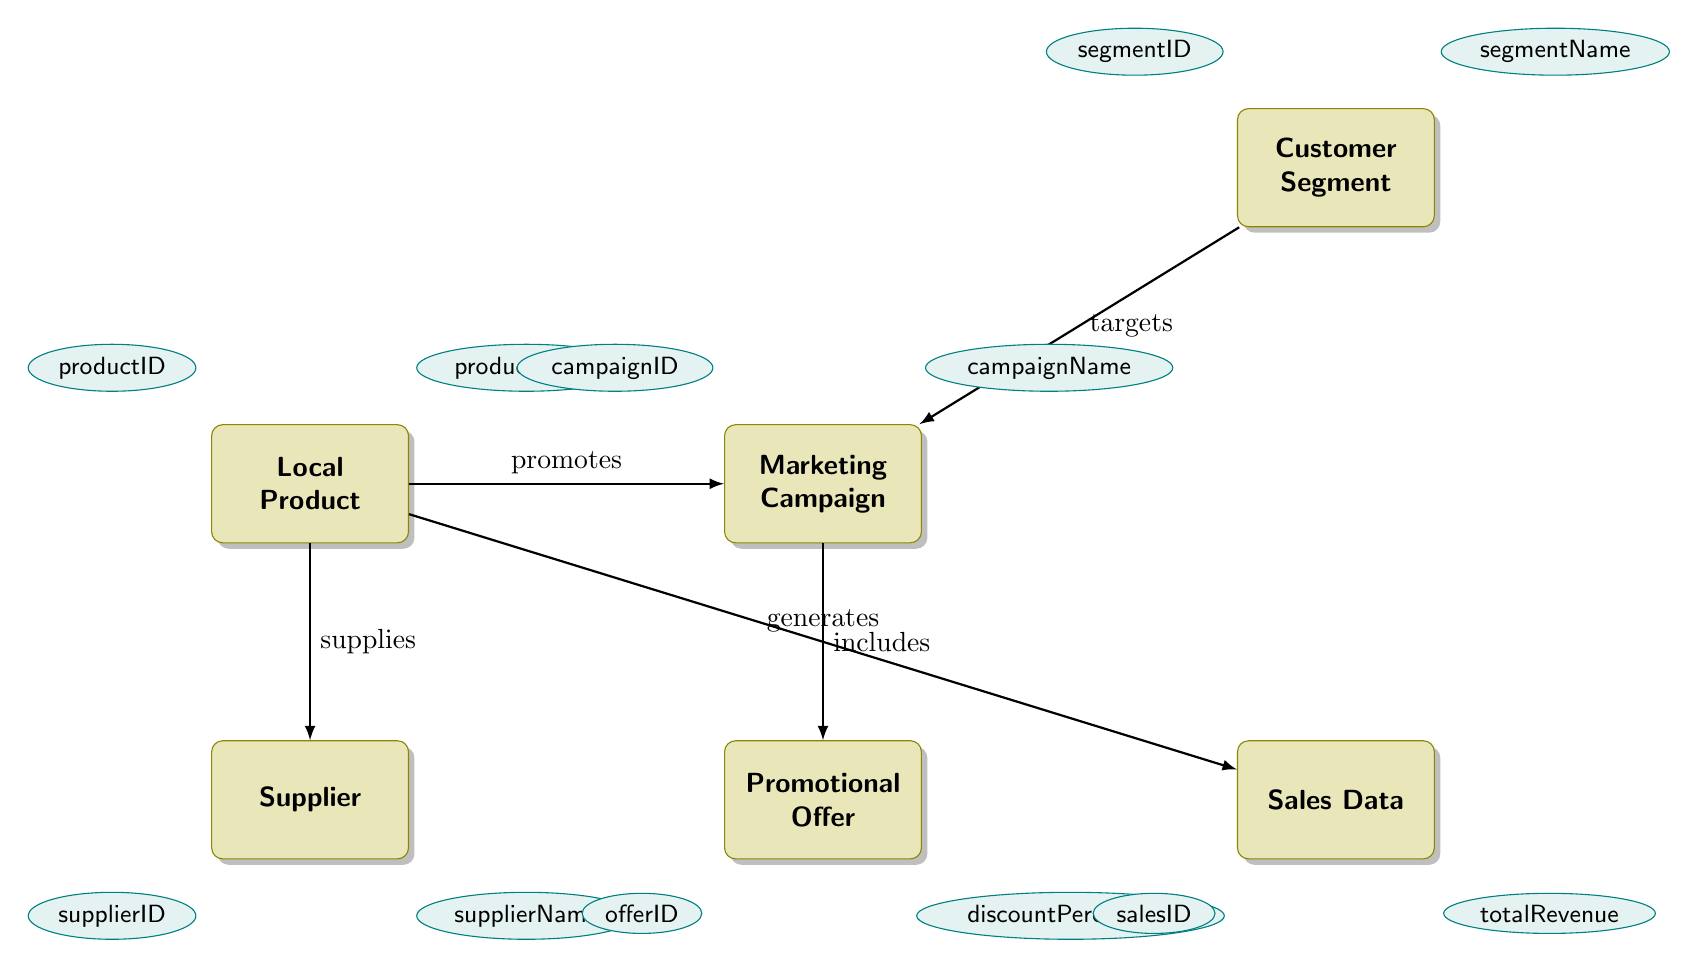What is the primary relationship between Local Product and Supplier? The diagram shows that Local Product has a "ManyToOne" relationship with Supplier, indicating that multiple local products can be supplied by a single supplier.
Answer: ManyToOne How many attributes does the Marketing Campaign entity have? By examining the Marketing Campaign entity in the diagram, we see that it has five attributes: campaignID, campaignName, startDate, endDate, and budget.
Answer: Five Which entity targets Customer Segments in the marketing structure? The diagram indicates that Marketing Campaign has a "ManyToMany" relationship with Customer Segment, meaning that Marketing Campaign targets Customer Segments.
Answer: Marketing Campaign What relationship exists between Marketing Campaign and Promotional Offer? The diagram specifies a "OneToMany" relationship between Marketing Campaign and Promotional Offer, meaning that a single marketing campaign can include multiple promotional offers.
Answer: OneToMany What is the total number of entities depicted in the diagram? Counting each distinct entity in the diagram, we find that there are six entities represented: Local Product, Supplier, Marketing Campaign, Promotional Offer, Customer Segment, and Sales Data.
Answer: Six What is the discount percentage attributed to Promotional Offers? The Promotional Offer entity includes an attribute specifically named discountPercentage, which provides the percentage that reflects the offer's discount.
Answer: discountPercentage Which entity generates Sales Data? The diagram shows that the Sales Data entity has a "ManyToOne" relationship with Local Product, indicating that sales data is generated from local products.
Answer: Local Product How does Local Product contribute to Marketing Campaigns? According to the diagram, Local Product has a "ManyToMany" relationship with Marketing Campaign, implying that multiple local products can be promoted through various marketing campaigns.
Answer: ManyToMany What key attribute identifies each Local Product? The diagram states that Local Product has an attribute called productID, which serves as the unique identifier for each local product.
Answer: productID 